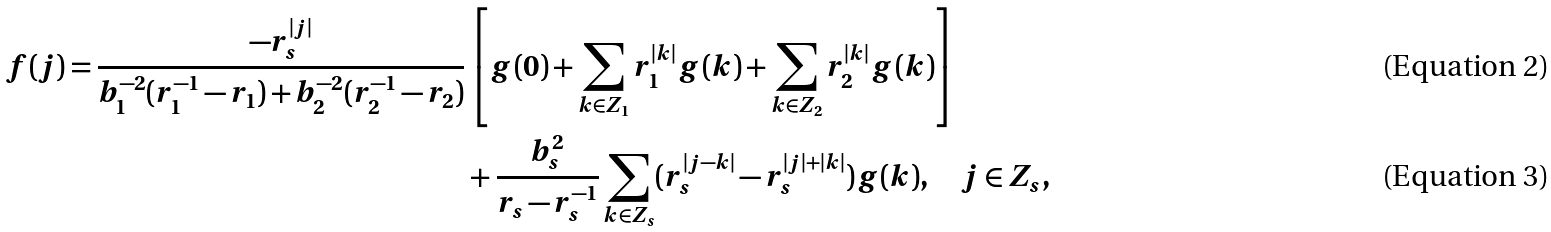Convert formula to latex. <formula><loc_0><loc_0><loc_500><loc_500>f ( j ) = \frac { - r _ { s } ^ { | j | } } { b _ { 1 } ^ { - 2 } ( r _ { 1 } ^ { - 1 } - r _ { 1 } ) + b _ { 2 } ^ { - 2 } ( r _ { 2 } ^ { - 1 } - r _ { 2 } ) } & \left [ g ( 0 ) + \sum _ { k \in Z _ { 1 } } r _ { 1 } ^ { | k | } g ( k ) + \sum _ { k \in Z _ { 2 } } r _ { 2 } ^ { | k | } g ( k ) \right ] \\ & + \frac { b _ { s } ^ { 2 } } { r _ { s } - r _ { s } ^ { - 1 } } \sum _ { k \in Z _ { s } } ( r _ { s } ^ { | j - k | } - r _ { s } ^ { | j | + | k | } ) g ( k ) , \quad j \in Z _ { s } ,</formula> 